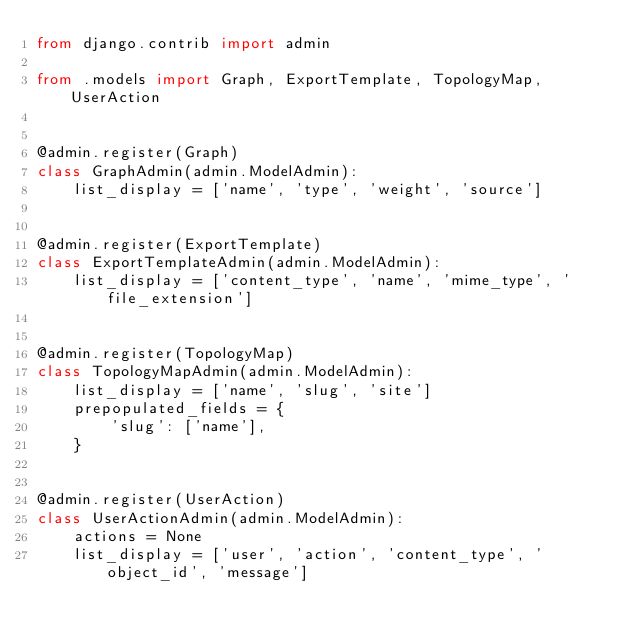<code> <loc_0><loc_0><loc_500><loc_500><_Python_>from django.contrib import admin

from .models import Graph, ExportTemplate, TopologyMap, UserAction


@admin.register(Graph)
class GraphAdmin(admin.ModelAdmin):
    list_display = ['name', 'type', 'weight', 'source']


@admin.register(ExportTemplate)
class ExportTemplateAdmin(admin.ModelAdmin):
    list_display = ['content_type', 'name', 'mime_type', 'file_extension']


@admin.register(TopologyMap)
class TopologyMapAdmin(admin.ModelAdmin):
    list_display = ['name', 'slug', 'site']
    prepopulated_fields = {
        'slug': ['name'],
    }


@admin.register(UserAction)
class UserActionAdmin(admin.ModelAdmin):
    actions = None
    list_display = ['user', 'action', 'content_type', 'object_id', 'message']
</code> 